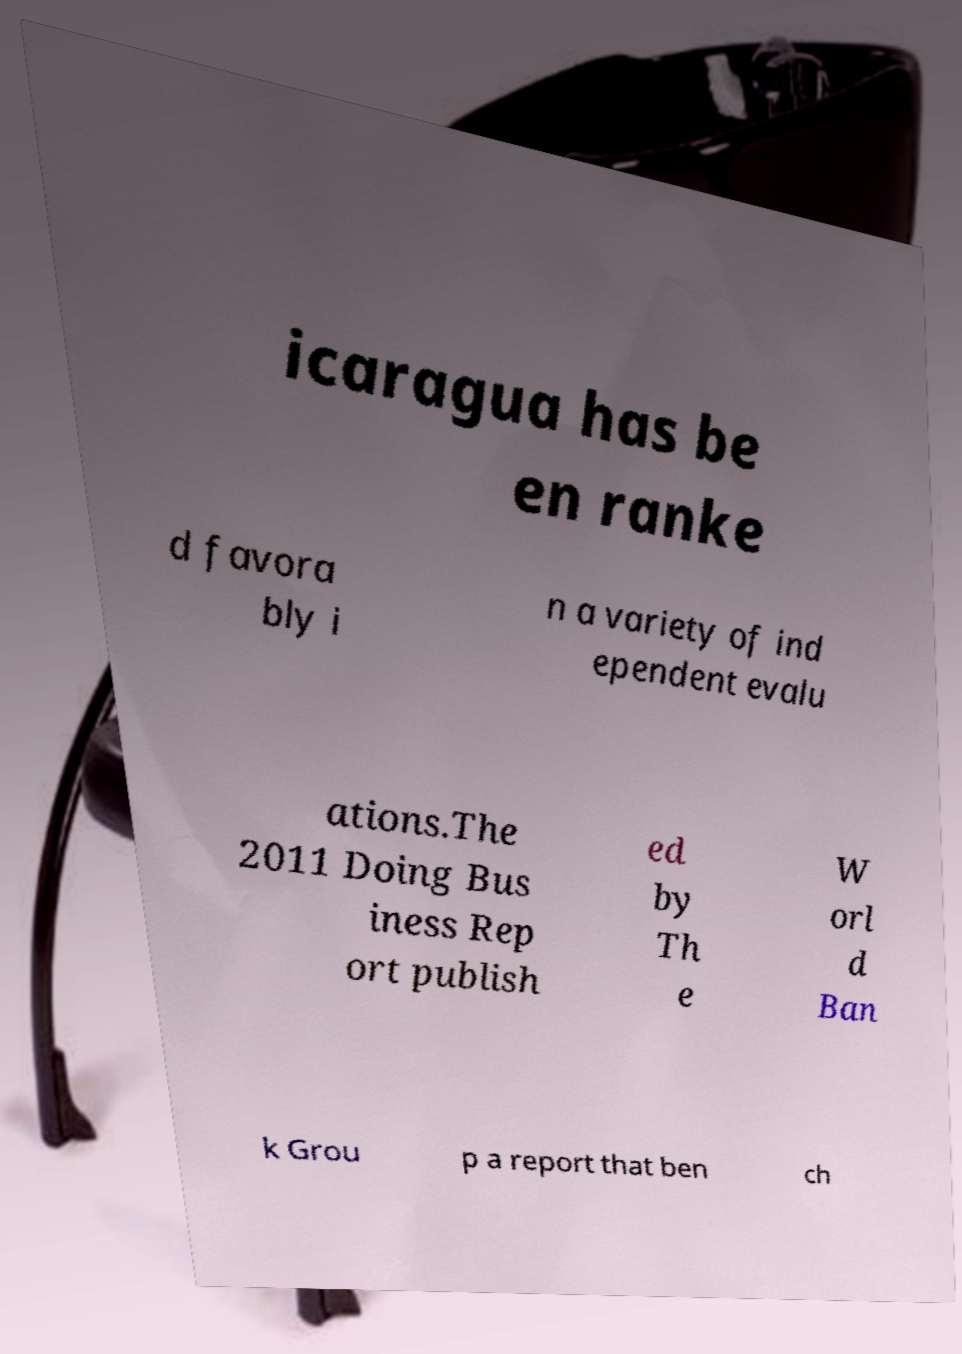Can you read and provide the text displayed in the image?This photo seems to have some interesting text. Can you extract and type it out for me? icaragua has be en ranke d favora bly i n a variety of ind ependent evalu ations.The 2011 Doing Bus iness Rep ort publish ed by Th e W orl d Ban k Grou p a report that ben ch 